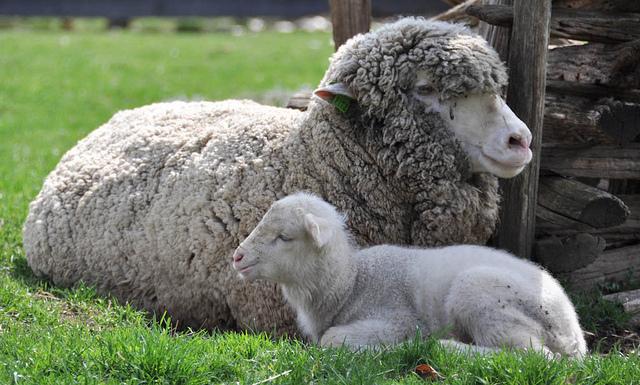What is front goat doing?
Keep it brief. Resting. What color tag is on the lamb?
Quick response, please. Green. How many animals are in the pic?
Answer briefly. 2. What color is the lamb?
Give a very brief answer. White. Is one of these lambs a baby?
Concise answer only. Yes. 